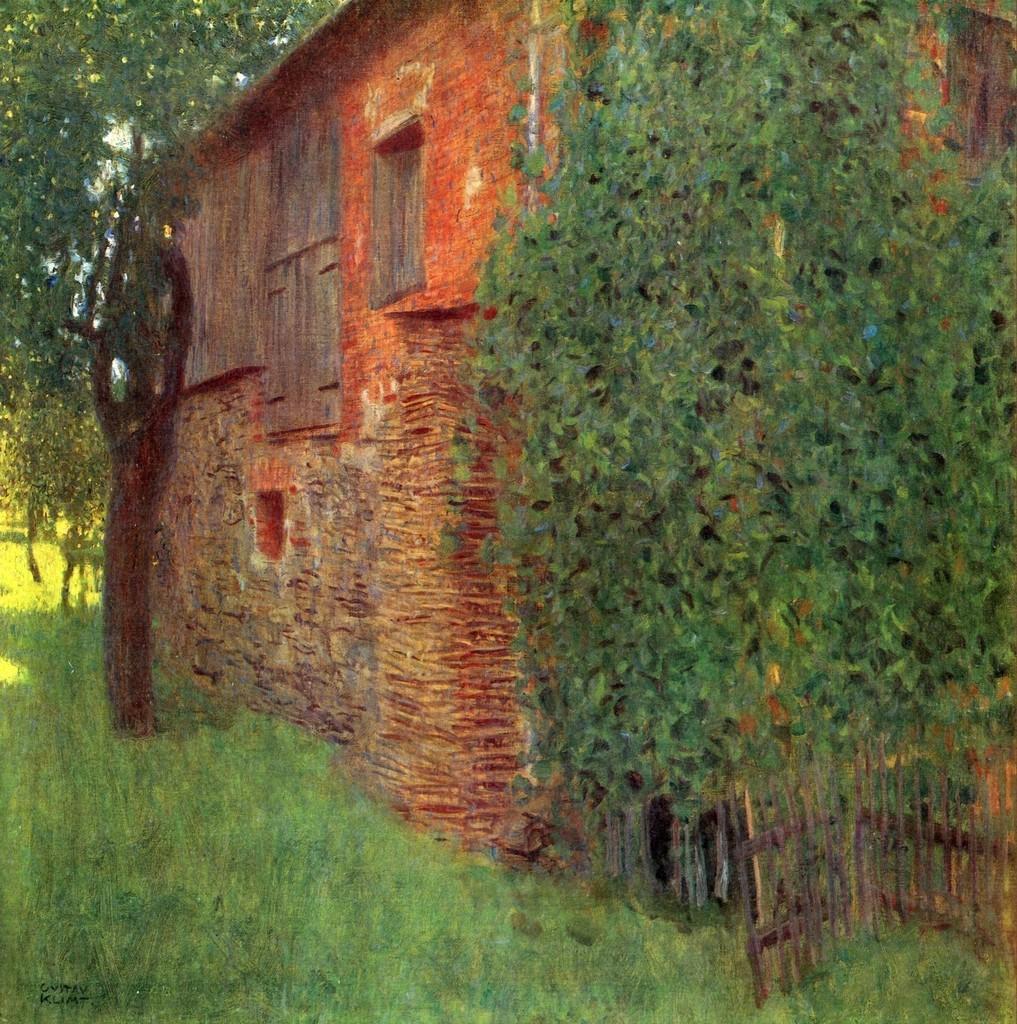In one or two sentences, can you explain what this image depicts? In this image there is a wall of a house. There are windows to the wall. In front of the wall there are trees. In the bottom right there is a wooden railing. At the bottom there is grass on the ground. The image seems to be a painting. 